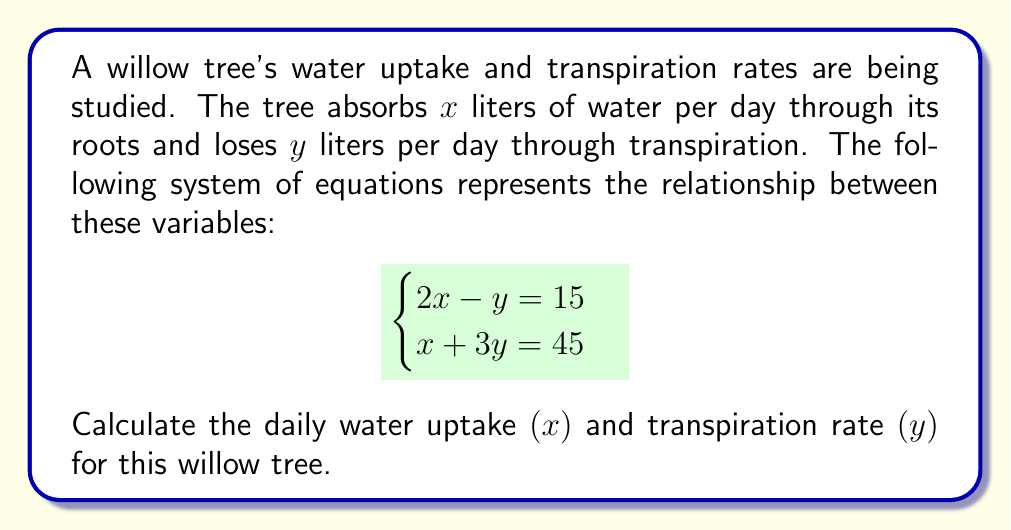Show me your answer to this math problem. To solve this system of equations, we can use the substitution method:

1) From the first equation, we can express $y$ in terms of $x$:
   $2x - y = 15$
   $y = 2x - 15$

2) Substitute this expression for $y$ into the second equation:
   $x + 3(2x - 15) = 45$

3) Simplify:
   $x + 6x - 45 = 45$
   $7x - 45 = 45$

4) Solve for $x$:
   $7x = 90$
   $x = \frac{90}{7} = 12.86$

5) Now that we know $x$, we can find $y$ using either of the original equations. Let's use the first one:
   $2x - y = 15$
   $2(12.86) - y = 15$
   $25.72 - y = 15$
   $y = 25.72 - 15 = 10.72$

6) Round the results to two decimal places:
   $x = 12.86$ liters/day
   $y = 10.72$ liters/day

Therefore, the willow tree absorbs 12.86 liters of water per day and loses 10.72 liters per day through transpiration.
Answer: Water uptake $(x)$: 12.86 liters/day
Transpiration rate $(y)$: 10.72 liters/day 